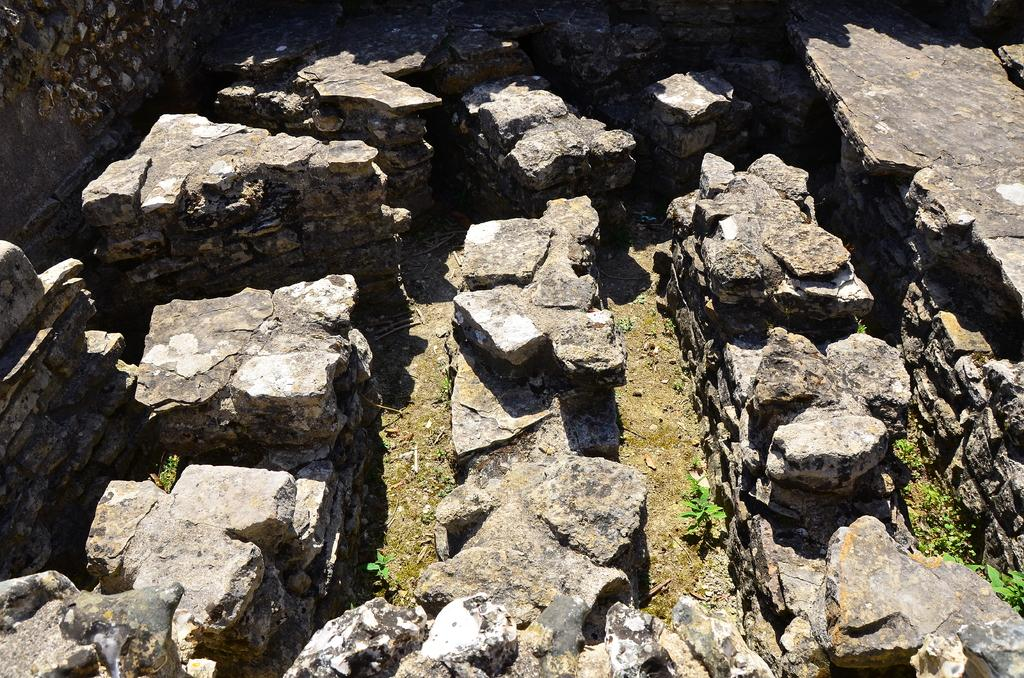What type of natural elements can be seen in the image? There are rocks in the image. What is surrounding the rocks in the image? The rocks are surrounded by a wall. What material is the wall made of? The wall is made up of stones. What type of ticket can be seen in the image? There is no ticket present in the image. Is there any writing visible on the rocks in the image? There is no writing visible on the rocks in the image. 